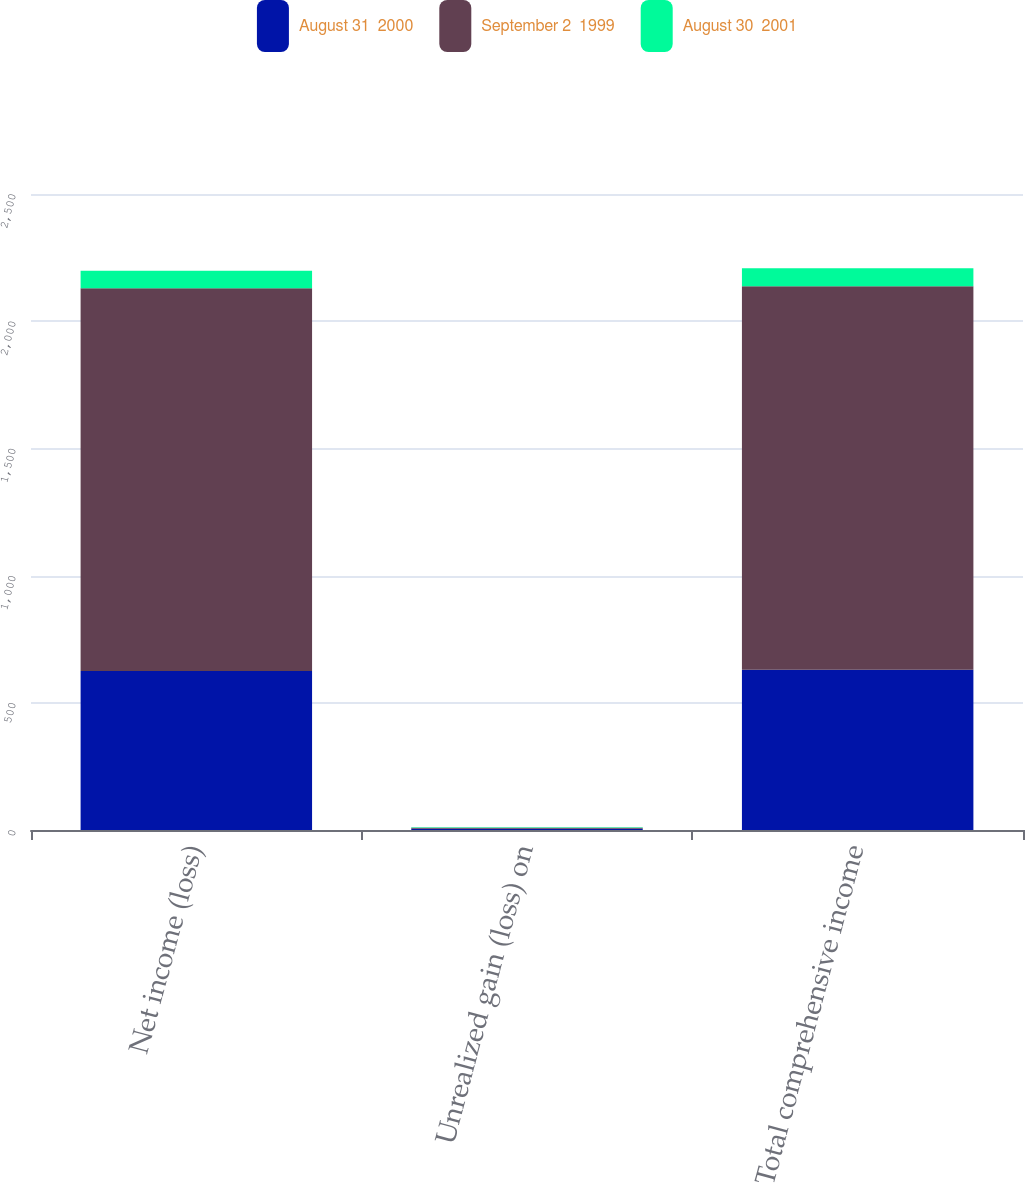Convert chart to OTSL. <chart><loc_0><loc_0><loc_500><loc_500><stacked_bar_chart><ecel><fcel>Net income (loss)<fcel>Unrealized gain (loss) on<fcel>Total comprehensive income<nl><fcel>August 31  2000<fcel>625<fcel>4.8<fcel>629.8<nl><fcel>September 2  1999<fcel>1504.2<fcel>3.6<fcel>1507.8<nl><fcel>August 30  2001<fcel>68.9<fcel>2<fcel>70.9<nl></chart> 